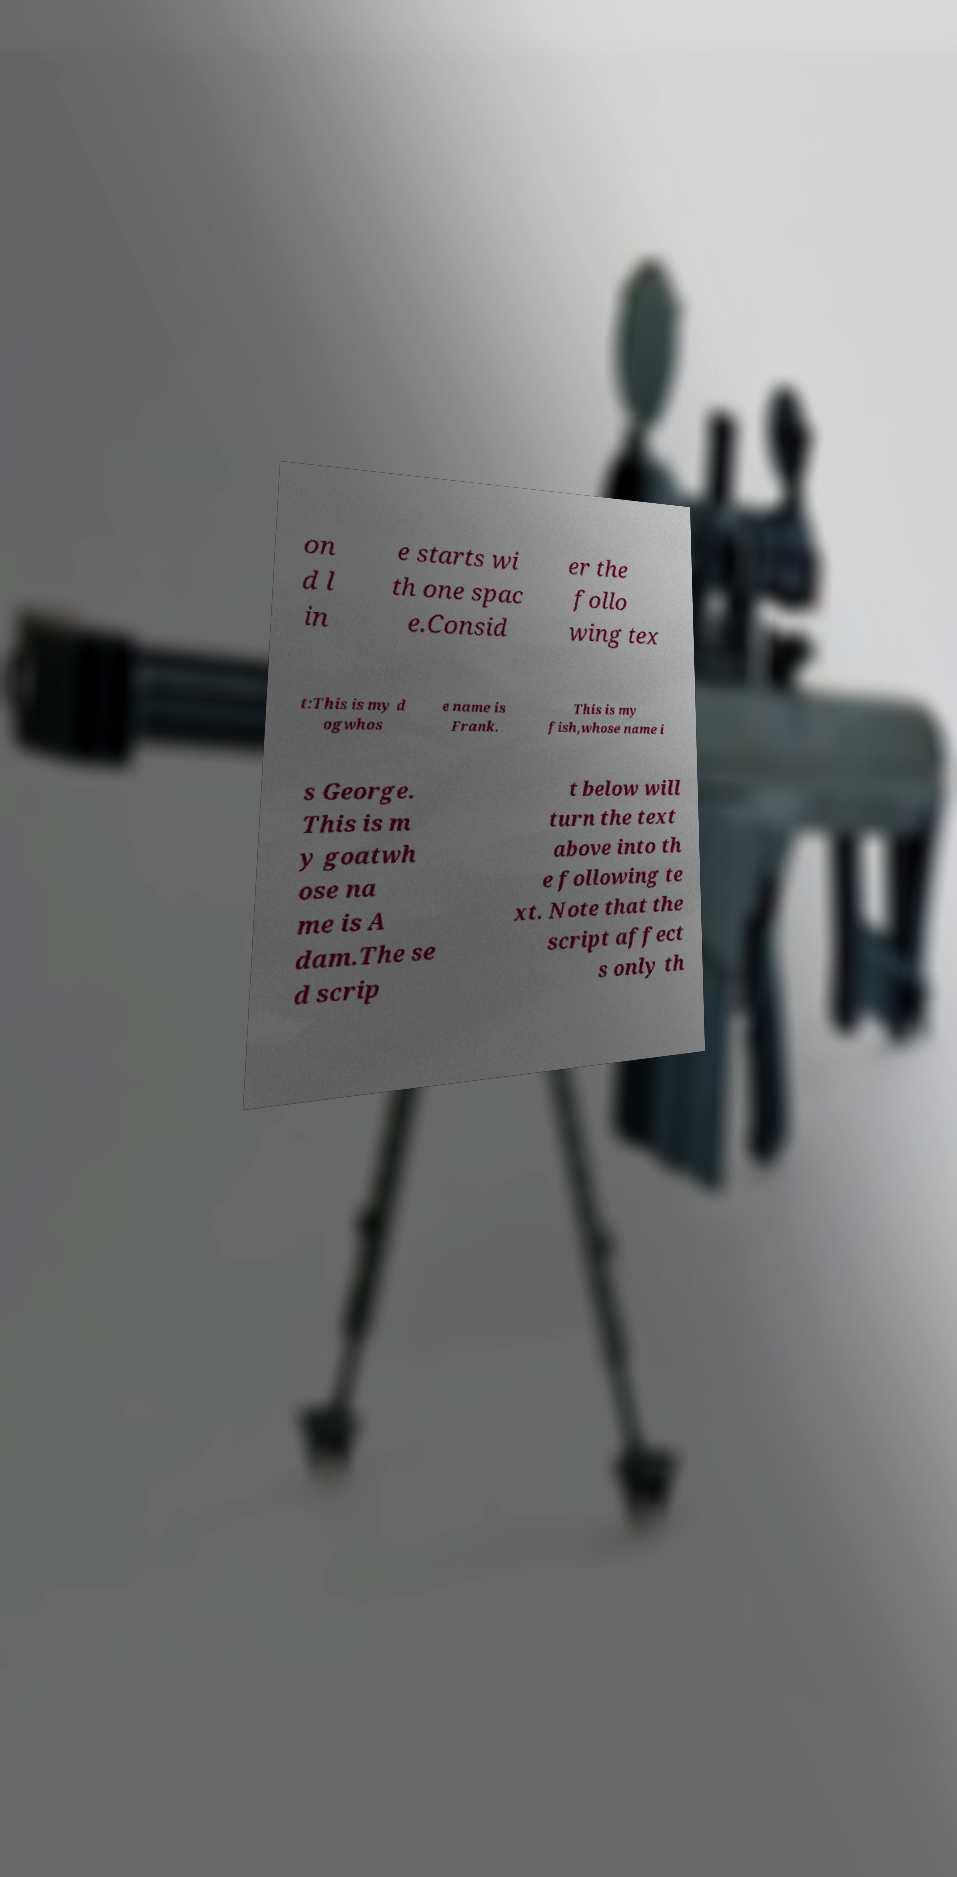Please identify and transcribe the text found in this image. on d l in e starts wi th one spac e.Consid er the follo wing tex t:This is my d ogwhos e name is Frank. This is my fish,whose name i s George. This is m y goatwh ose na me is A dam.The se d scrip t below will turn the text above into th e following te xt. Note that the script affect s only th 